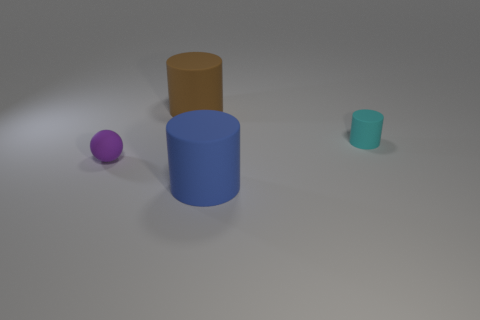Add 2 small purple rubber balls. How many objects exist? 6 Subtract all cylinders. How many objects are left? 1 Subtract all big brown cylinders. Subtract all small rubber objects. How many objects are left? 1 Add 3 big brown matte cylinders. How many big brown matte cylinders are left? 4 Add 2 small yellow balls. How many small yellow balls exist? 2 Subtract 0 green cylinders. How many objects are left? 4 